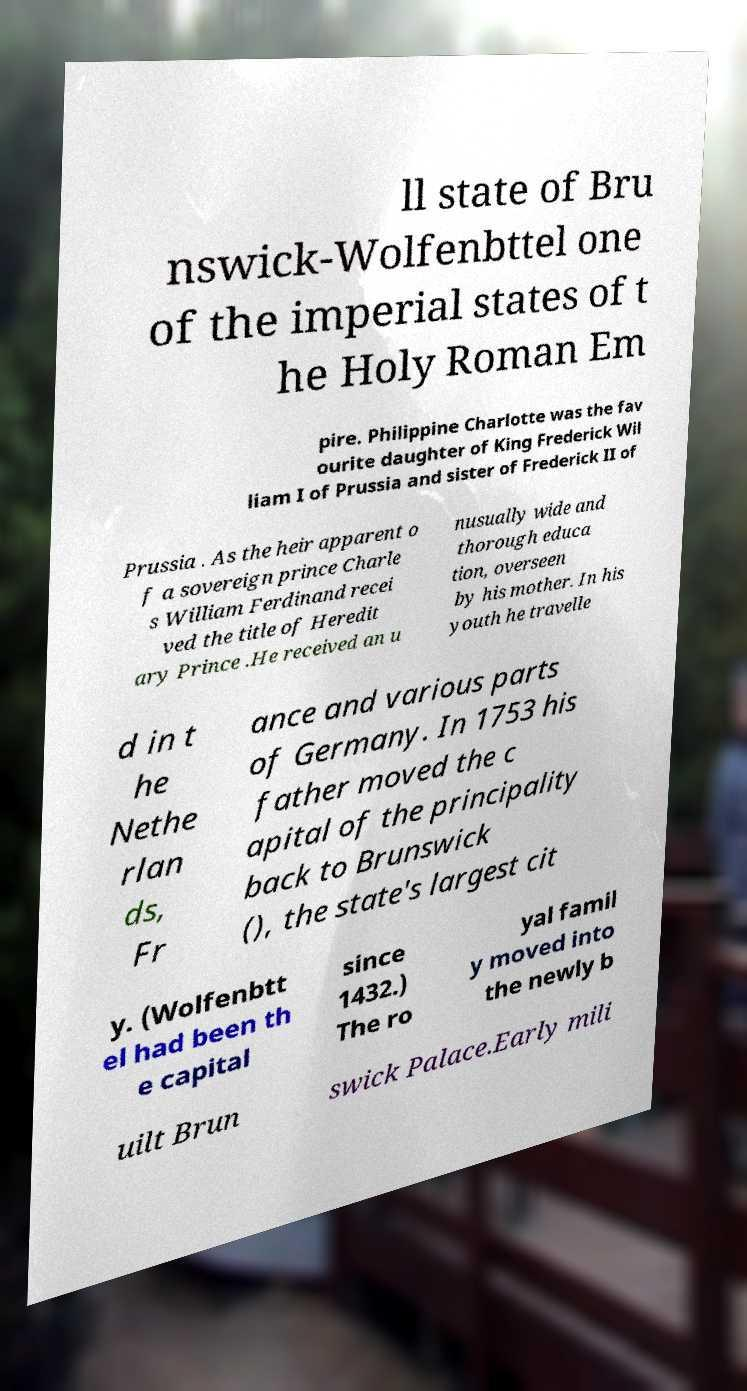There's text embedded in this image that I need extracted. Can you transcribe it verbatim? ll state of Bru nswick-Wolfenbttel one of the imperial states of t he Holy Roman Em pire. Philippine Charlotte was the fav ourite daughter of King Frederick Wil liam I of Prussia and sister of Frederick II of Prussia . As the heir apparent o f a sovereign prince Charle s William Ferdinand recei ved the title of Heredit ary Prince .He received an u nusually wide and thorough educa tion, overseen by his mother. In his youth he travelle d in t he Nethe rlan ds, Fr ance and various parts of Germany. In 1753 his father moved the c apital of the principality back to Brunswick (), the state's largest cit y. (Wolfenbtt el had been th e capital since 1432.) The ro yal famil y moved into the newly b uilt Brun swick Palace.Early mili 